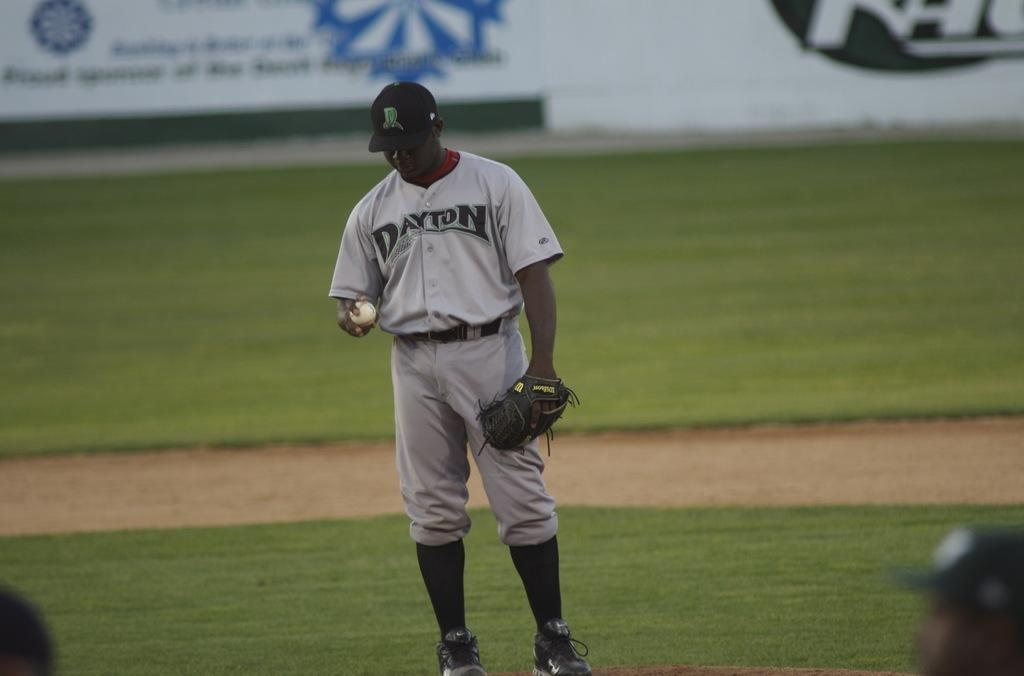<image>
Render a clear and concise summary of the photo. A baseball player for team Dayton holds the ball in his hand. 